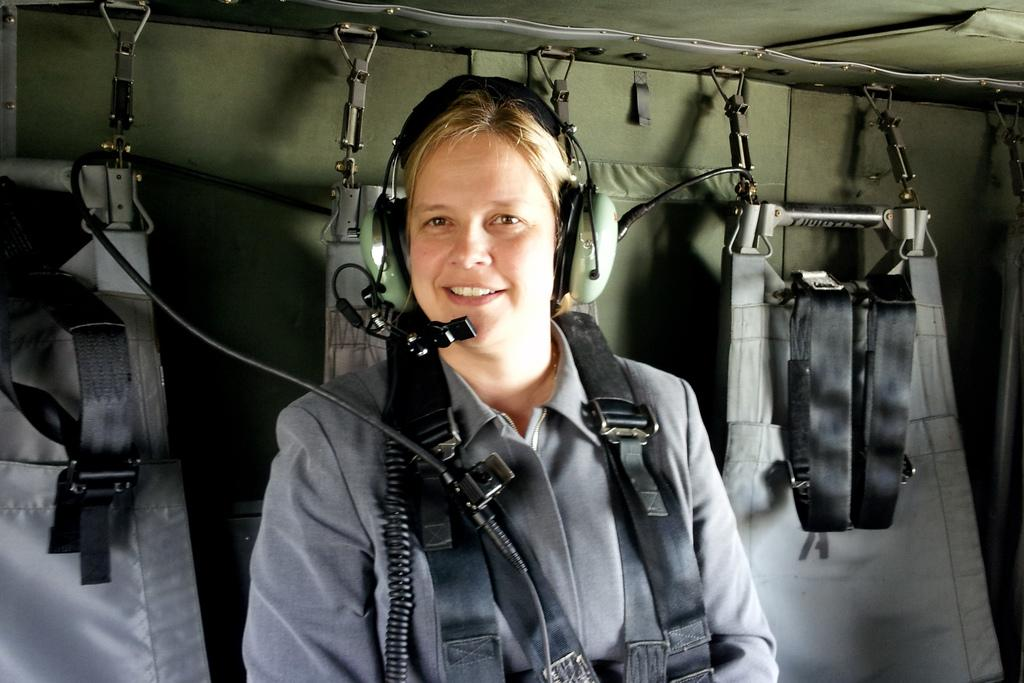Who is the main subject in the image? There is a woman in the center of the image. What is the woman wearing in the image? The woman is wearing a headset in the image. What is the woman's facial expression in the image? The woman is smiling in the image. What can be seen in the background of the image? There are costumes and a cloth-like object in the background of the image. Are there any other objects visible in the background? Yes, there are wires in the background of the image. What is the woman's health condition in the image? There is no information about the woman's health condition in the image. Can you tell me if the seashore is visible in the image? There is no seashore visible in the image. 